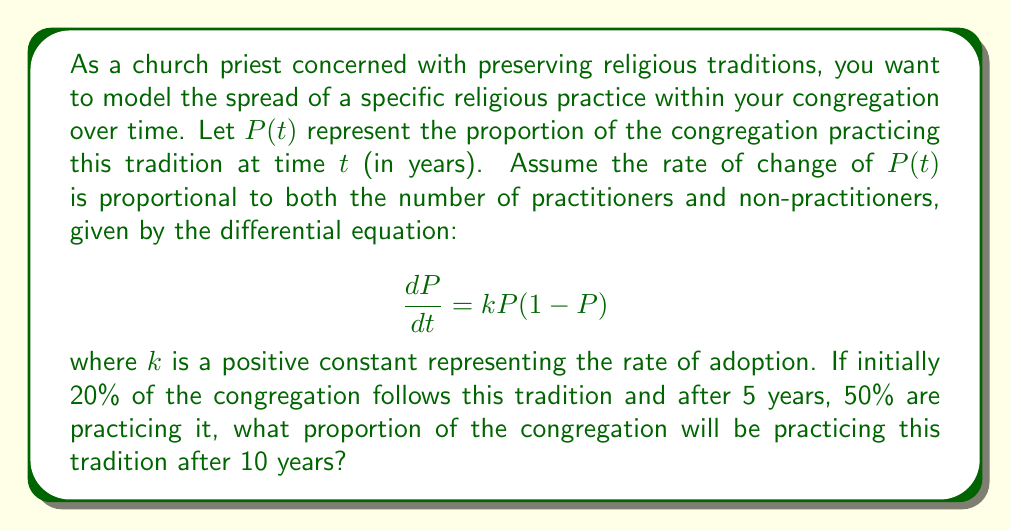What is the answer to this math problem? Let's solve this problem step by step:

1) The given differential equation is a logistic growth model:
   $$\frac{dP}{dt} = kP(1-P)$$

2) The solution to this equation is:
   $$P(t) = \frac{1}{1 + Ce^{-kt}}$$
   where $C$ is a constant determined by the initial condition.

3) Given $P(0) = 0.2$, we can find $C$:
   $$0.2 = \frac{1}{1 + C} \implies C = 4$$

4) Now our equation is:
   $$P(t) = \frac{1}{1 + 4e^{-kt}}$$

5) We're told that $P(5) = 0.5$. Let's use this to find $k$:
   $$0.5 = \frac{1}{1 + 4e^{-5k}}$$
   $$1 = 1 + 4e^{-5k}$$
   $$0 = 4e^{-5k}$$
   $$e^{-5k} = \frac{1}{4}$$
   $$-5k = \ln(\frac{1}{4}) = -\ln(4)$$
   $$k = \frac{\ln(4)}{5}$$

6) Now we have our complete model:
   $$P(t) = \frac{1}{1 + 4e^{-\frac{\ln(4)}{5}t}}$$

7) To find $P(10)$, we simply plug in $t = 10$:
   $$P(10) = \frac{1}{1 + 4e^{-\frac{\ln(4)}{5}10}}$$
   $$= \frac{1}{1 + 4e^{-2\ln(4)}}$$
   $$= \frac{1}{1 + 4 \cdot \frac{1}{16}}$$
   $$= \frac{1}{1 + \frac{1}{4}} = \frac{1}{\frac{5}{4}} = \frac{4}{5} = 0.8$$

Therefore, after 10 years, 80% of the congregation will be practicing this religious tradition.
Answer: $0.8$ or $80\%$ 